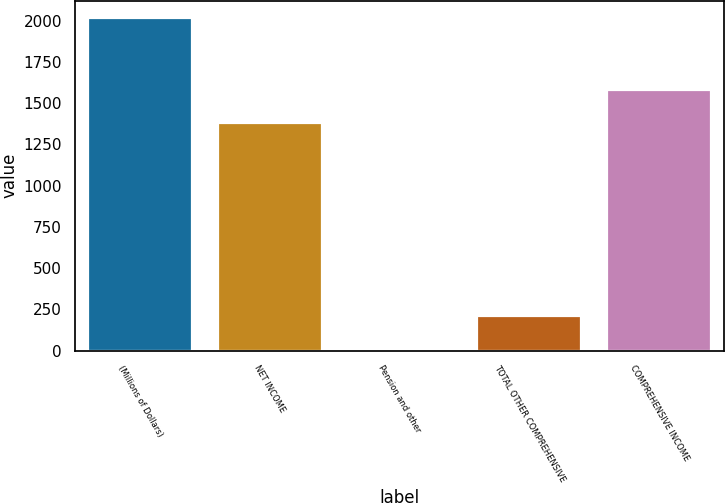<chart> <loc_0><loc_0><loc_500><loc_500><bar_chart><fcel>(Millions of Dollars)<fcel>NET INCOME<fcel>Pension and other<fcel>TOTAL OTHER COMPREHENSIVE<fcel>COMPREHENSIVE INCOME<nl><fcel>2018<fcel>1382<fcel>10<fcel>210.8<fcel>1582.8<nl></chart> 